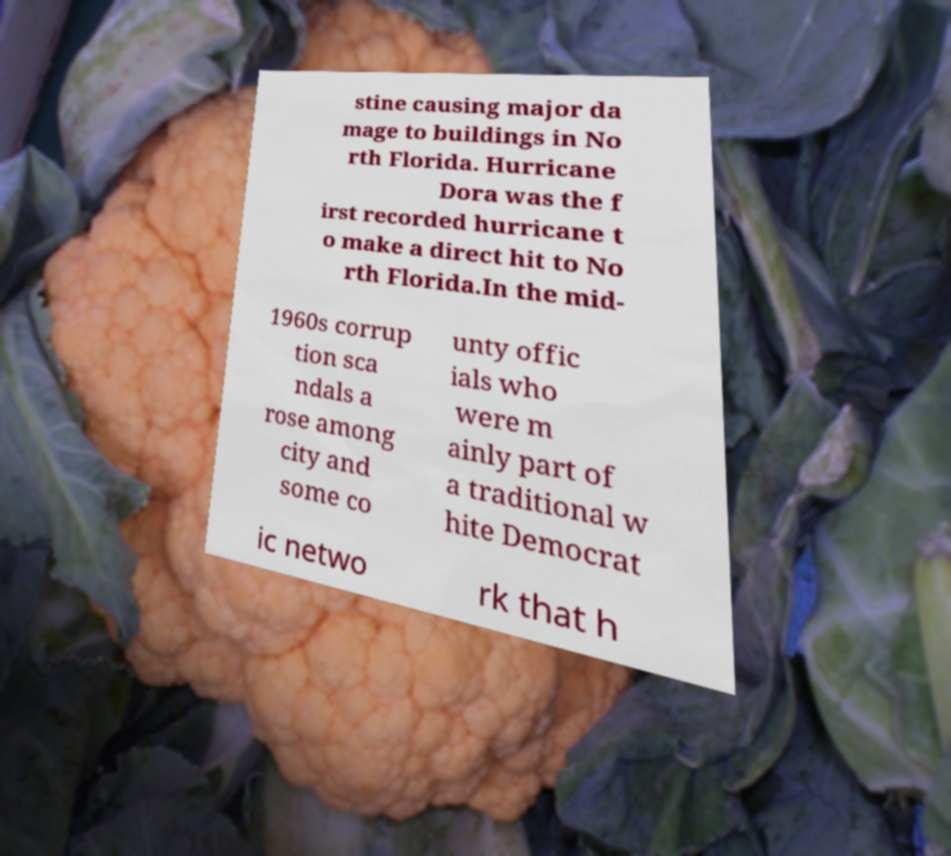Could you extract and type out the text from this image? stine causing major da mage to buildings in No rth Florida. Hurricane Dora was the f irst recorded hurricane t o make a direct hit to No rth Florida.In the mid- 1960s corrup tion sca ndals a rose among city and some co unty offic ials who were m ainly part of a traditional w hite Democrat ic netwo rk that h 